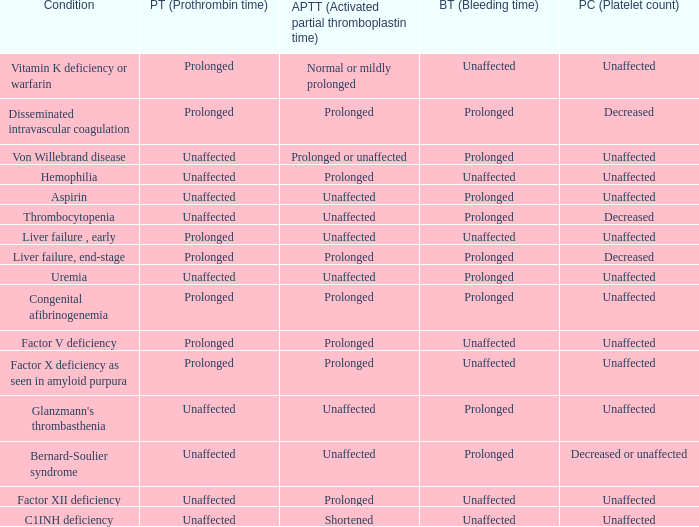Which Bleeding time has a Condition of factor x deficiency as seen in amyloid purpura? Unaffected. 